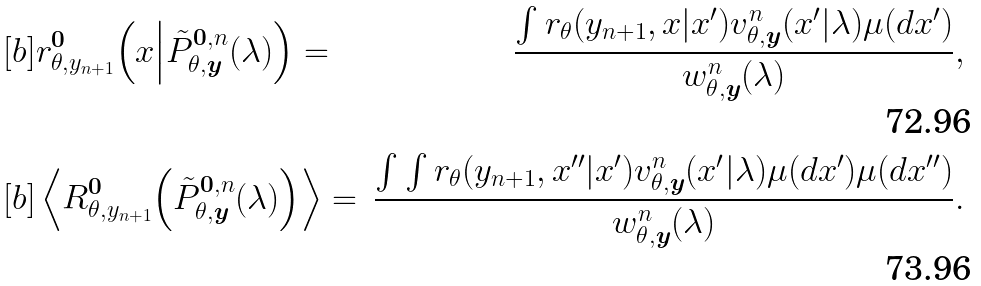Convert formula to latex. <formula><loc_0><loc_0><loc_500><loc_500>& [ b ] r _ { \theta , y _ { n + 1 } } ^ { \boldsymbol 0 } \Big ( x \Big | \tilde { P } _ { \theta , \boldsymbol y } ^ { \boldsymbol 0 , n } ( \lambda ) \Big ) = & \frac { \int r _ { \theta } ( y _ { n + 1 } , x | x ^ { \prime } ) v _ { \theta , \boldsymbol y } ^ { n } ( x ^ { \prime } | \lambda ) \mu ( d x ^ { \prime } ) } { w _ { \theta , \boldsymbol y } ^ { n } ( \lambda ) } , \\ & [ b ] \left \langle R _ { \theta , y _ { n + 1 } } ^ { \boldsymbol 0 } \Big ( \tilde { P } _ { \theta , \boldsymbol y } ^ { \boldsymbol 0 , n } ( \lambda ) \Big ) \right \rangle = & \frac { \int \int r _ { \theta } ( y _ { n + 1 } , x ^ { \prime \prime } | x ^ { \prime } ) v _ { \theta , \boldsymbol y } ^ { n } ( x ^ { \prime } | \lambda ) \mu ( d x ^ { \prime } ) \mu ( d x ^ { \prime \prime } ) } { w _ { \theta , \boldsymbol y } ^ { n } ( \lambda ) } .</formula> 